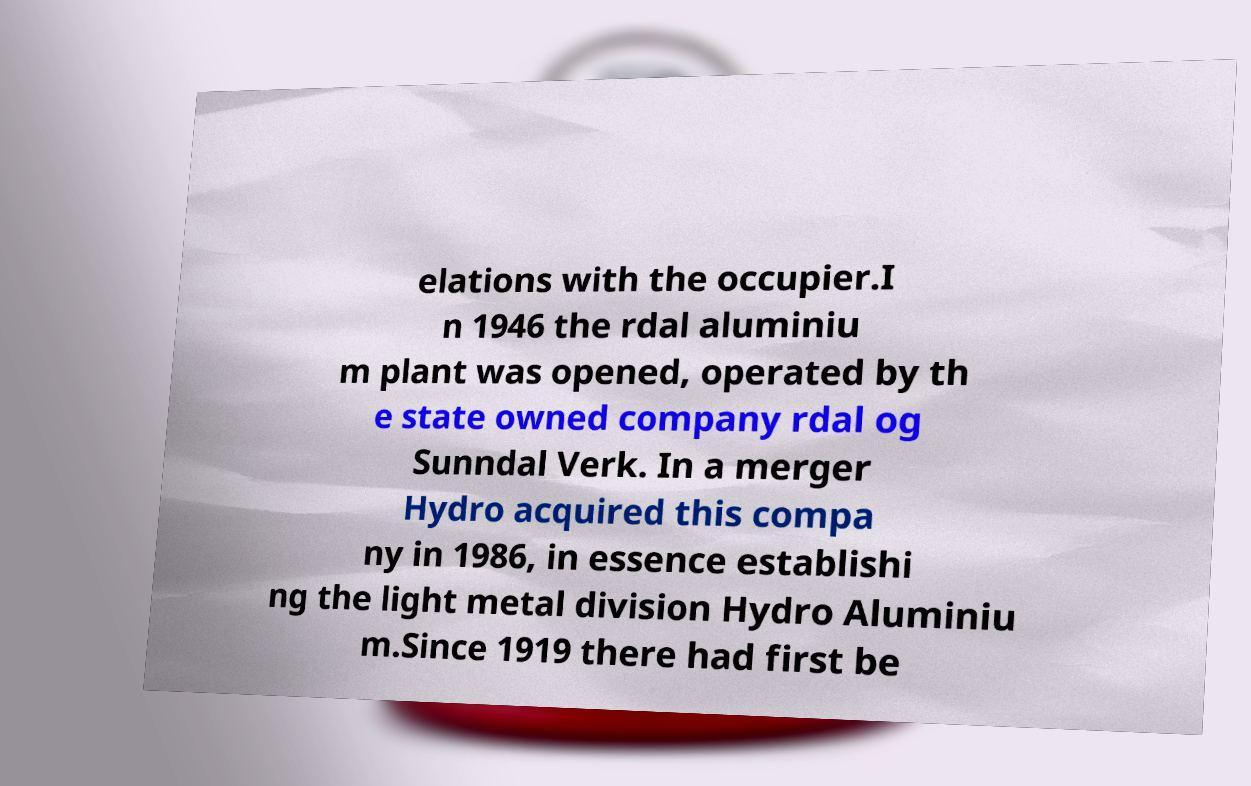Can you accurately transcribe the text from the provided image for me? elations with the occupier.I n 1946 the rdal aluminiu m plant was opened, operated by th e state owned company rdal og Sunndal Verk. In a merger Hydro acquired this compa ny in 1986, in essence establishi ng the light metal division Hydro Aluminiu m.Since 1919 there had first be 